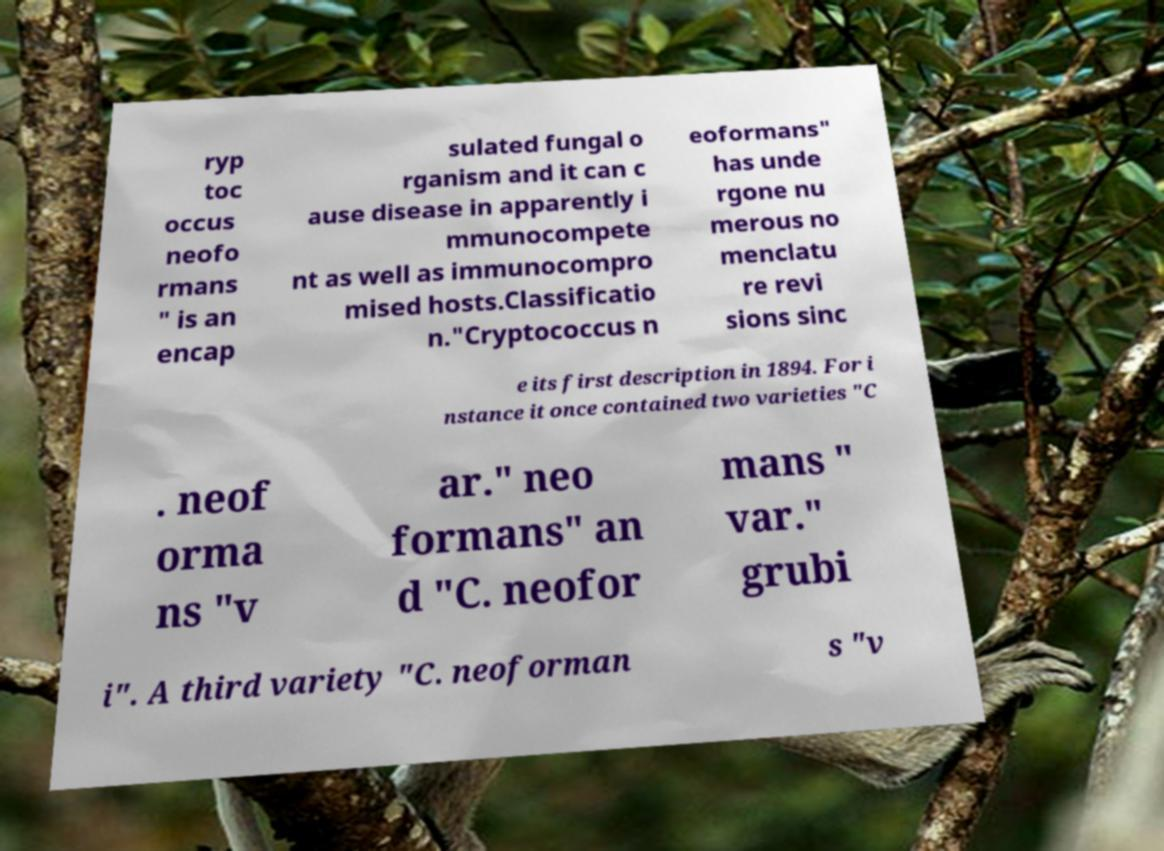Could you extract and type out the text from this image? ryp toc occus neofo rmans " is an encap sulated fungal o rganism and it can c ause disease in apparently i mmunocompete nt as well as immunocompro mised hosts.Classificatio n."Cryptococcus n eoformans" has unde rgone nu merous no menclatu re revi sions sinc e its first description in 1894. For i nstance it once contained two varieties "C . neof orma ns "v ar." neo formans" an d "C. neofor mans " var." grubi i". A third variety "C. neoforman s "v 